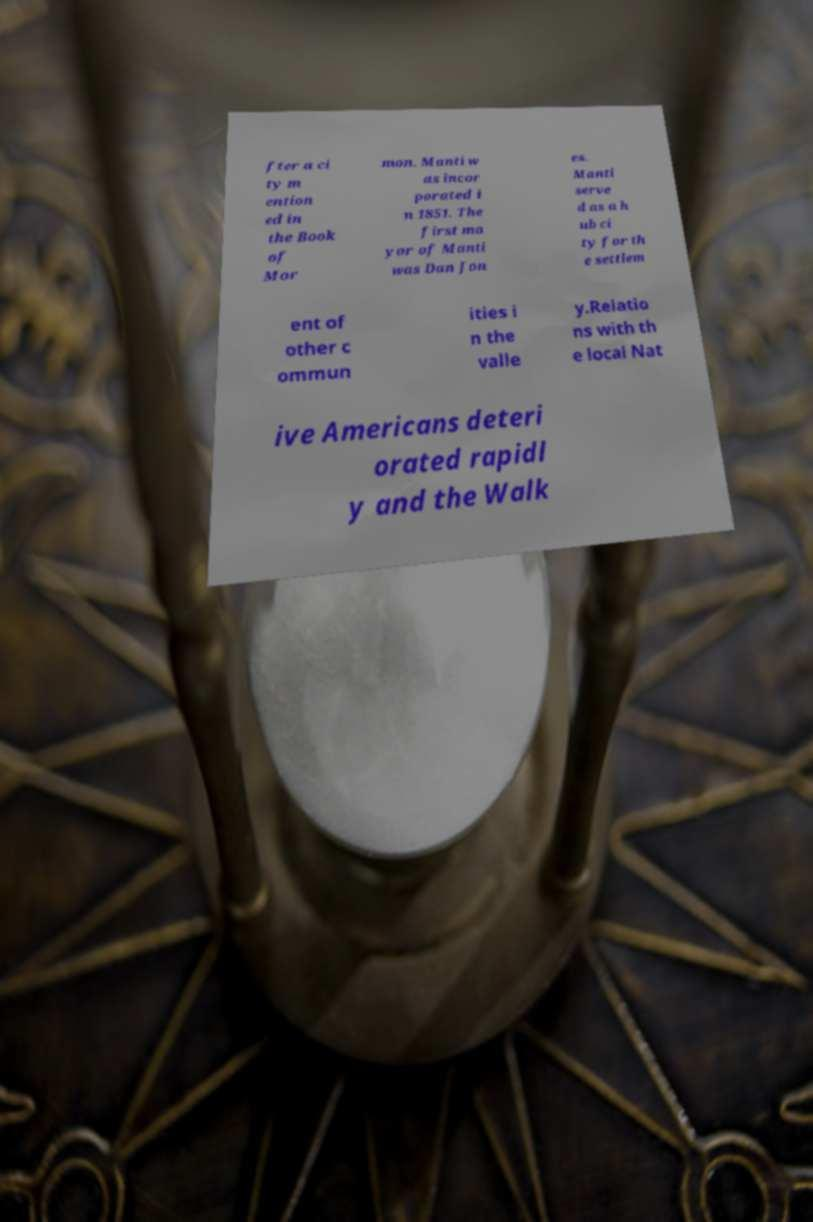Can you read and provide the text displayed in the image?This photo seems to have some interesting text. Can you extract and type it out for me? fter a ci ty m ention ed in the Book of Mor mon. Manti w as incor porated i n 1851. The first ma yor of Manti was Dan Jon es. Manti serve d as a h ub ci ty for th e settlem ent of other c ommun ities i n the valle y.Relatio ns with th e local Nat ive Americans deteri orated rapidl y and the Walk 